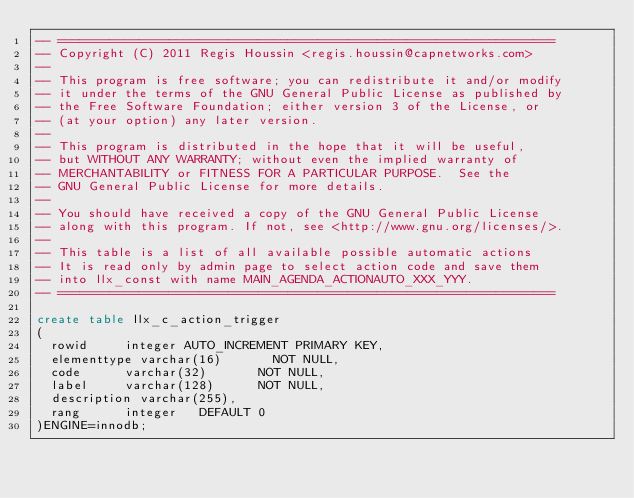Convert code to text. <code><loc_0><loc_0><loc_500><loc_500><_SQL_>-- ===================================================================
-- Copyright (C) 2011 Regis Houssin	<regis.houssin@capnetworks.com>
--
-- This program is free software; you can redistribute it and/or modify
-- it under the terms of the GNU General Public License as published by
-- the Free Software Foundation; either version 3 of the License, or
-- (at your option) any later version.
--
-- This program is distributed in the hope that it will be useful,
-- but WITHOUT ANY WARRANTY; without even the implied warranty of
-- MERCHANTABILITY or FITNESS FOR A PARTICULAR PURPOSE.  See the
-- GNU General Public License for more details.
--
-- You should have received a copy of the GNU General Public License
-- along with this program. If not, see <http://www.gnu.org/licenses/>.
--
-- This table is a list of all available possible automatic actions
-- It is read only by admin page to select action code and save them 
-- into llx_const with name MAIN_AGENDA_ACTIONAUTO_XXX_YYY.
-- ===================================================================

create table llx_c_action_trigger
(
  rowid			integer AUTO_INCREMENT PRIMARY KEY,
  elementtype	varchar(16) 			NOT NULL,
  code			varchar(32)				NOT NULL,
  label			varchar(128)			NOT NULL,
  description	varchar(255),
  rang			integer		DEFAULT 0
)ENGINE=innodb;
</code> 